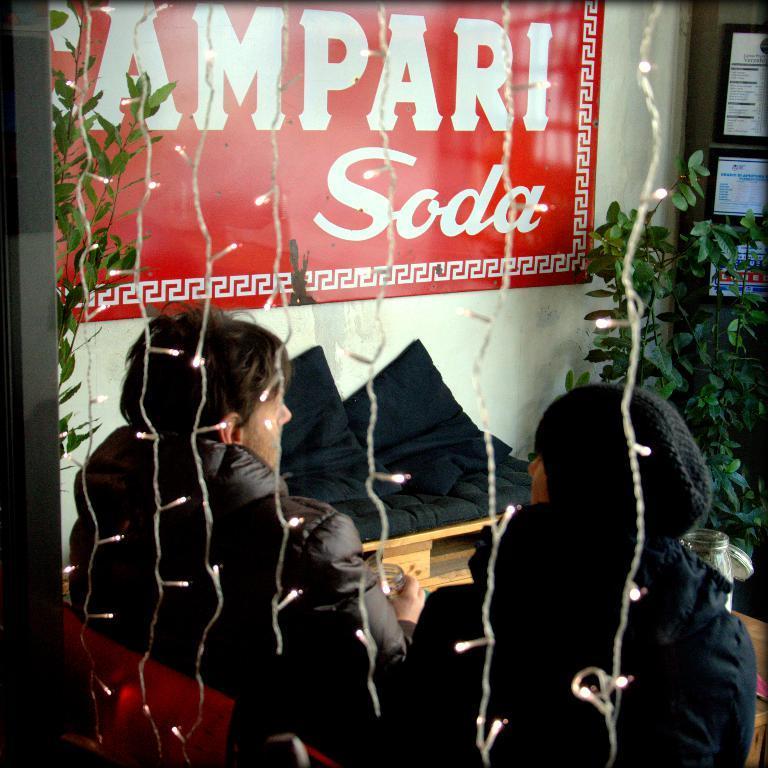How would you summarize this image in a sentence or two? This picture seems to be clicked inside the room. In the foreground we can see the two people wearing jackets and seems to be sitting on the chairs and we can see the tables on the top of which some items are placed. In the background, we can see the wall, the text on the poster which is attached to the wall and we can see the green leaves and some devices and we can see the decoration lights. 